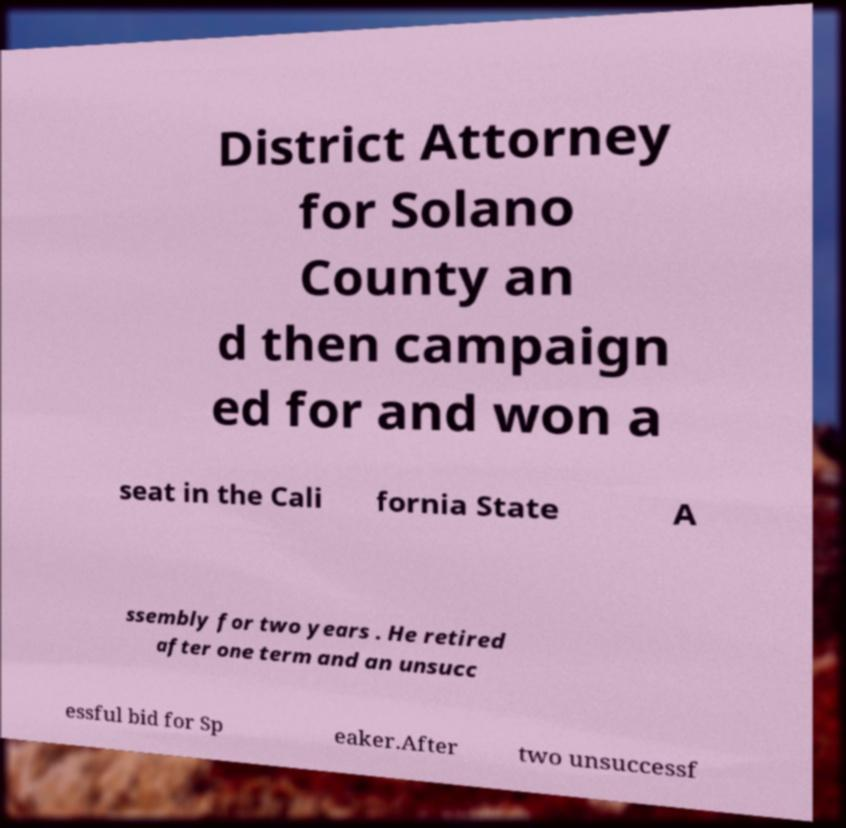What messages or text are displayed in this image? I need them in a readable, typed format. District Attorney for Solano County an d then campaign ed for and won a seat in the Cali fornia State A ssembly for two years . He retired after one term and an unsucc essful bid for Sp eaker.After two unsuccessf 